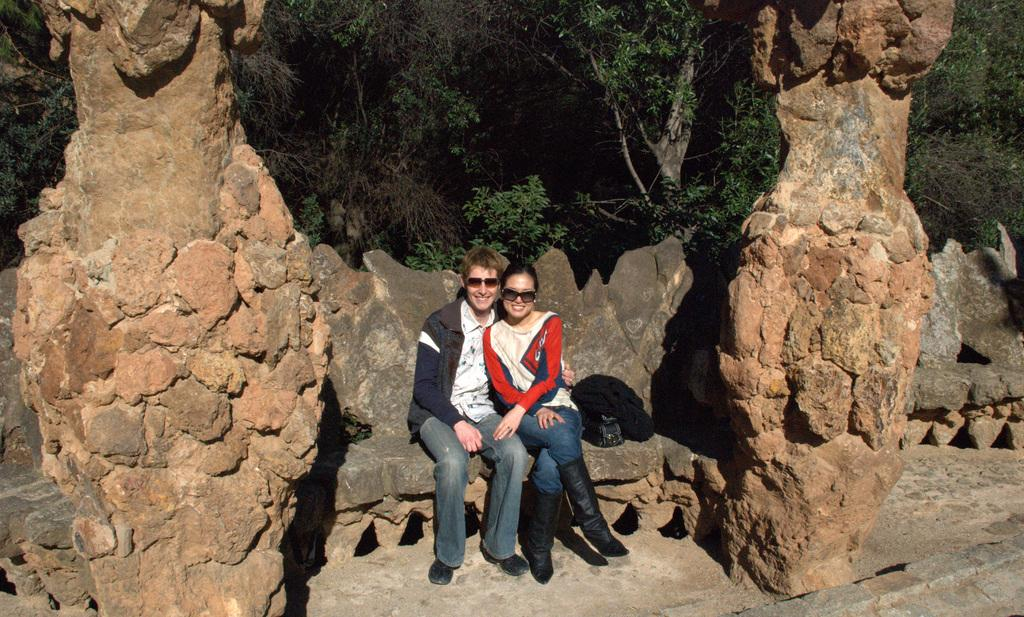How many people are in the image? There are two persons in the image. What are the persons doing in the image? The persons are sitting and smiling. What object can be seen in the image? There is a bag in the image. What type of natural elements are present in the image? There are rocks and trees in the image. What can be seen in the background of the image? There are trees in the background of the image. How many babies are crawling on the rocks in the image? There are no babies present in the image, and no one is crawling on the rocks. What type of protest is taking place in the image? There is no protest depicted in the image. 